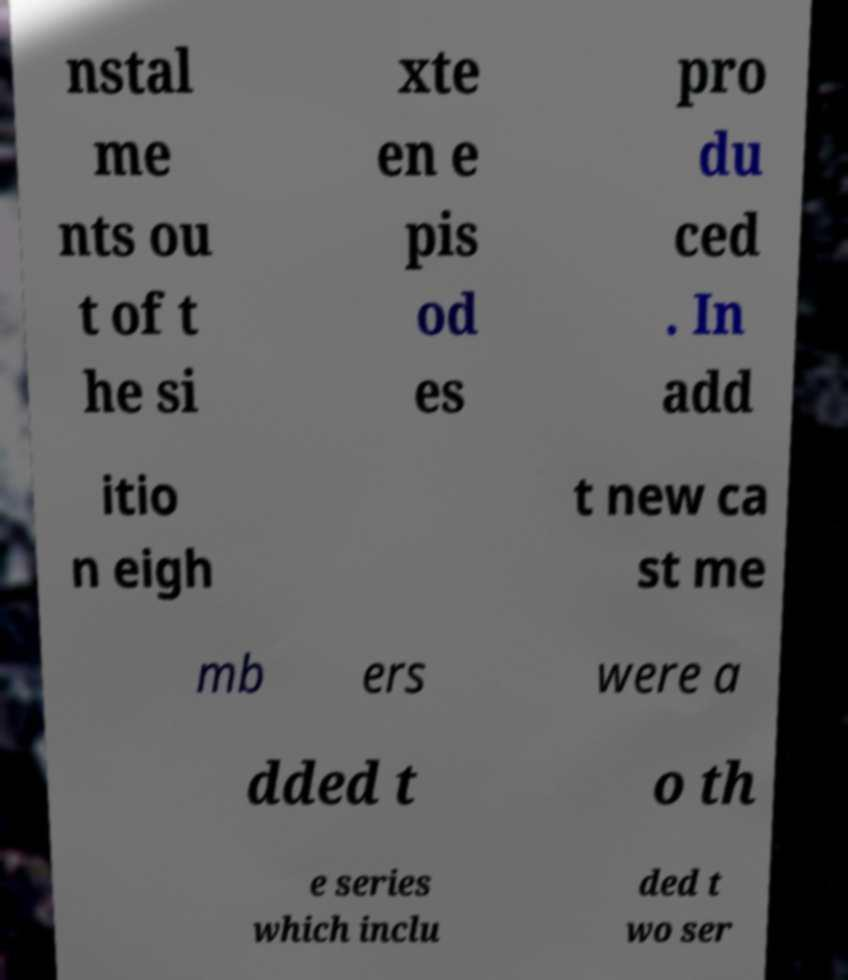For documentation purposes, I need the text within this image transcribed. Could you provide that? nstal me nts ou t of t he si xte en e pis od es pro du ced . In add itio n eigh t new ca st me mb ers were a dded t o th e series which inclu ded t wo ser 